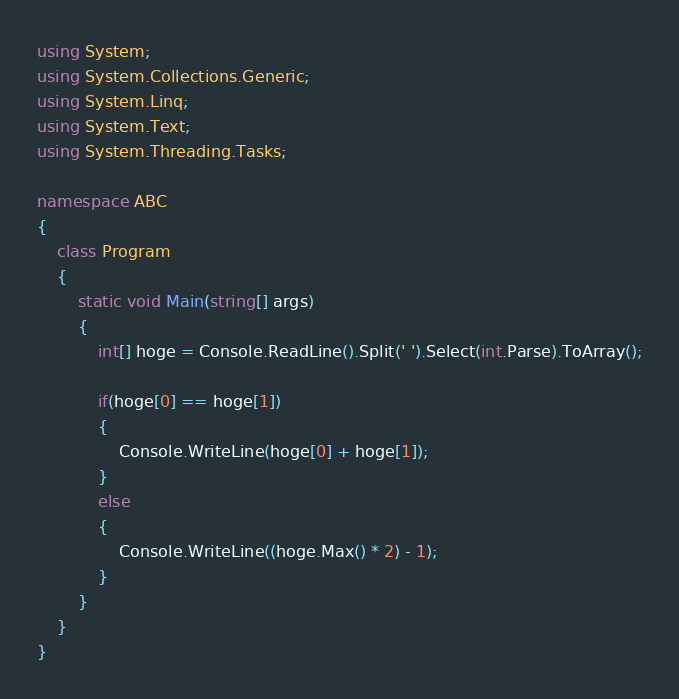Convert code to text. <code><loc_0><loc_0><loc_500><loc_500><_C#_>using System;
using System.Collections.Generic;
using System.Linq;
using System.Text;
using System.Threading.Tasks;

namespace ABC
{
    class Program
    {
        static void Main(string[] args)
        {
            int[] hoge = Console.ReadLine().Split(' ').Select(int.Parse).ToArray();

            if(hoge[0] == hoge[1])
            {
                Console.WriteLine(hoge[0] + hoge[1]);
            }
            else
            {
                Console.WriteLine((hoge.Max() * 2) - 1);
            }
        }
    }
}
</code> 